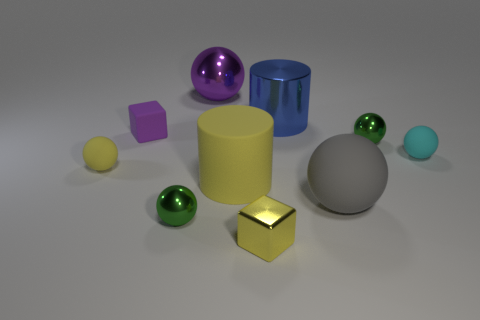Is the material of the small green thing that is to the left of the big yellow thing the same as the purple thing in front of the shiny cylinder? Based on the visual information, the small green object, which appears to be a smaller green sphere, does not look to be made of the same material as the purple object, a cube. The green sphere has a reflective surface indicating a potentially glossy material like glass or polished stone, whereas the purple cube seems to have a matte finish, which could suggest a plastic or painted wood material. 